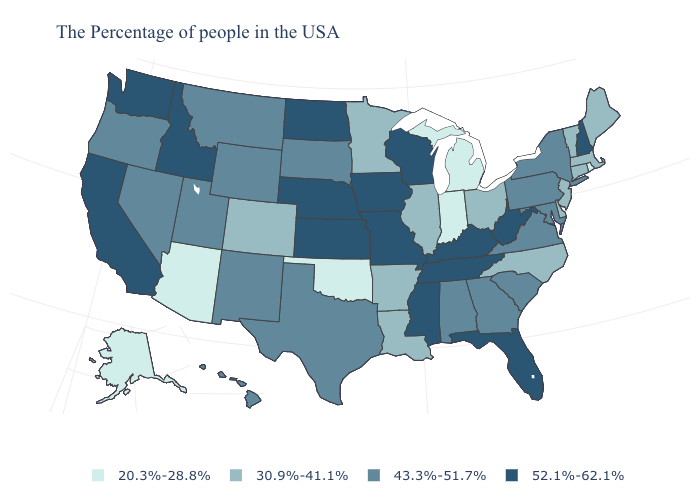Does the map have missing data?
Short answer required. No. Which states have the lowest value in the West?
Quick response, please. Arizona, Alaska. Among the states that border Alabama , does Georgia have the lowest value?
Answer briefly. Yes. What is the value of Kansas?
Concise answer only. 52.1%-62.1%. Name the states that have a value in the range 30.9%-41.1%?
Keep it brief. Maine, Massachusetts, Vermont, Connecticut, New Jersey, Delaware, North Carolina, Ohio, Illinois, Louisiana, Arkansas, Minnesota, Colorado. Does California have a higher value than Oregon?
Quick response, please. Yes. Does New Hampshire have the highest value in the Northeast?
Give a very brief answer. Yes. Does Michigan have the highest value in the MidWest?
Concise answer only. No. Name the states that have a value in the range 30.9%-41.1%?
Be succinct. Maine, Massachusetts, Vermont, Connecticut, New Jersey, Delaware, North Carolina, Ohio, Illinois, Louisiana, Arkansas, Minnesota, Colorado. Name the states that have a value in the range 30.9%-41.1%?
Write a very short answer. Maine, Massachusetts, Vermont, Connecticut, New Jersey, Delaware, North Carolina, Ohio, Illinois, Louisiana, Arkansas, Minnesota, Colorado. Which states have the highest value in the USA?
Give a very brief answer. New Hampshire, West Virginia, Florida, Kentucky, Tennessee, Wisconsin, Mississippi, Missouri, Iowa, Kansas, Nebraska, North Dakota, Idaho, California, Washington. Name the states that have a value in the range 30.9%-41.1%?
Quick response, please. Maine, Massachusetts, Vermont, Connecticut, New Jersey, Delaware, North Carolina, Ohio, Illinois, Louisiana, Arkansas, Minnesota, Colorado. Which states have the lowest value in the Northeast?
Give a very brief answer. Rhode Island. What is the value of Mississippi?
Answer briefly. 52.1%-62.1%. 